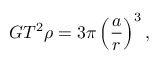Convert formula to latex. <formula><loc_0><loc_0><loc_500><loc_500>G T ^ { 2 } \rho = 3 \pi \left ( { \frac { a } { r } } \right ) ^ { 3 } ,</formula> 